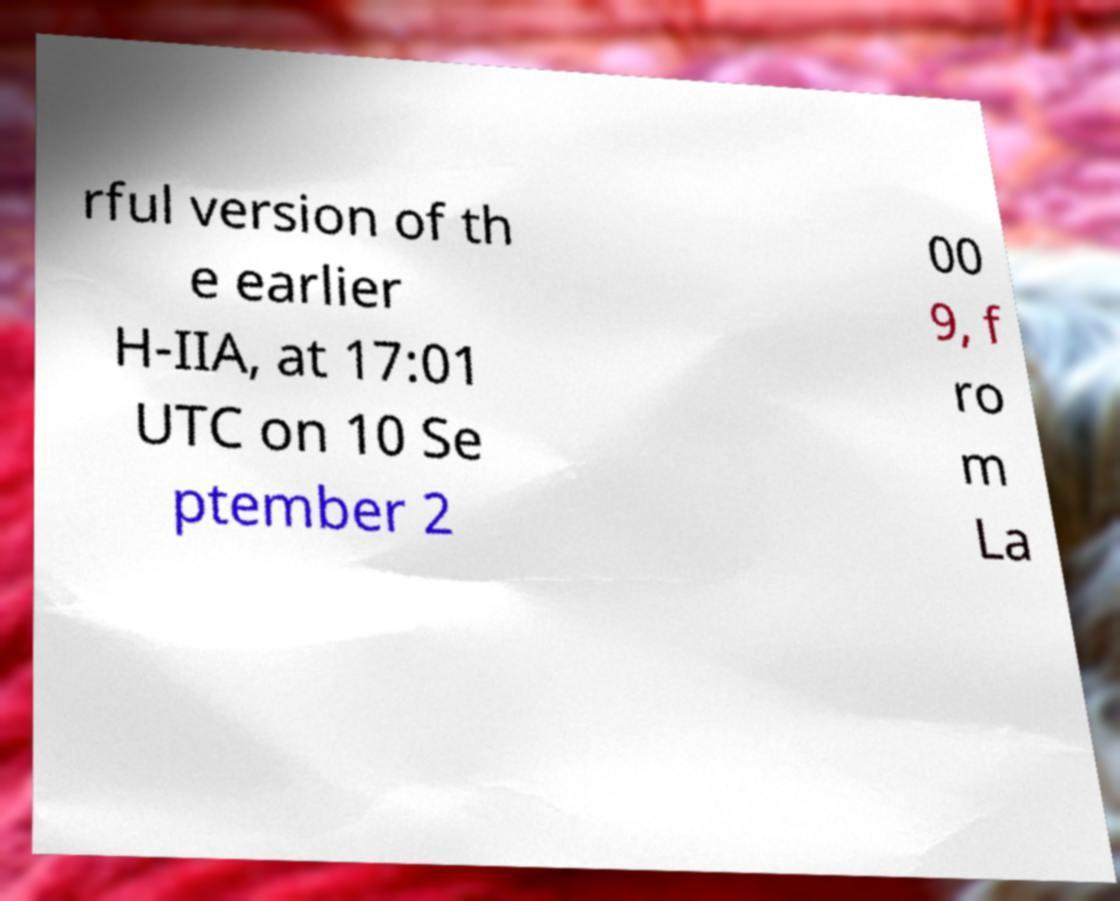What messages or text are displayed in this image? I need them in a readable, typed format. rful version of th e earlier H-IIA, at 17:01 UTC on 10 Se ptember 2 00 9, f ro m La 